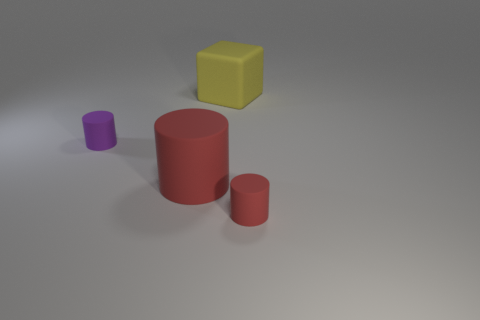Is there anything else that is the same shape as the yellow object?
Your response must be concise. No. What shape is the matte object that is to the left of the big yellow matte cube and in front of the small purple matte cylinder?
Your answer should be very brief. Cylinder. Are there any tiny metal spheres of the same color as the large cylinder?
Offer a terse response. No. Is there a small purple rubber cylinder?
Give a very brief answer. Yes. There is a cylinder left of the big rubber cylinder; what is its color?
Your answer should be very brief. Purple. Does the yellow cube have the same size as the cylinder right of the large red thing?
Your answer should be very brief. No. How big is the cylinder that is in front of the small purple rubber object and behind the tiny red thing?
Your answer should be very brief. Large. Are there any other large cylinders made of the same material as the large cylinder?
Keep it short and to the point. No. There is a tiny purple matte object; what shape is it?
Your answer should be very brief. Cylinder. Do the yellow block and the purple rubber cylinder have the same size?
Provide a short and direct response. No. 